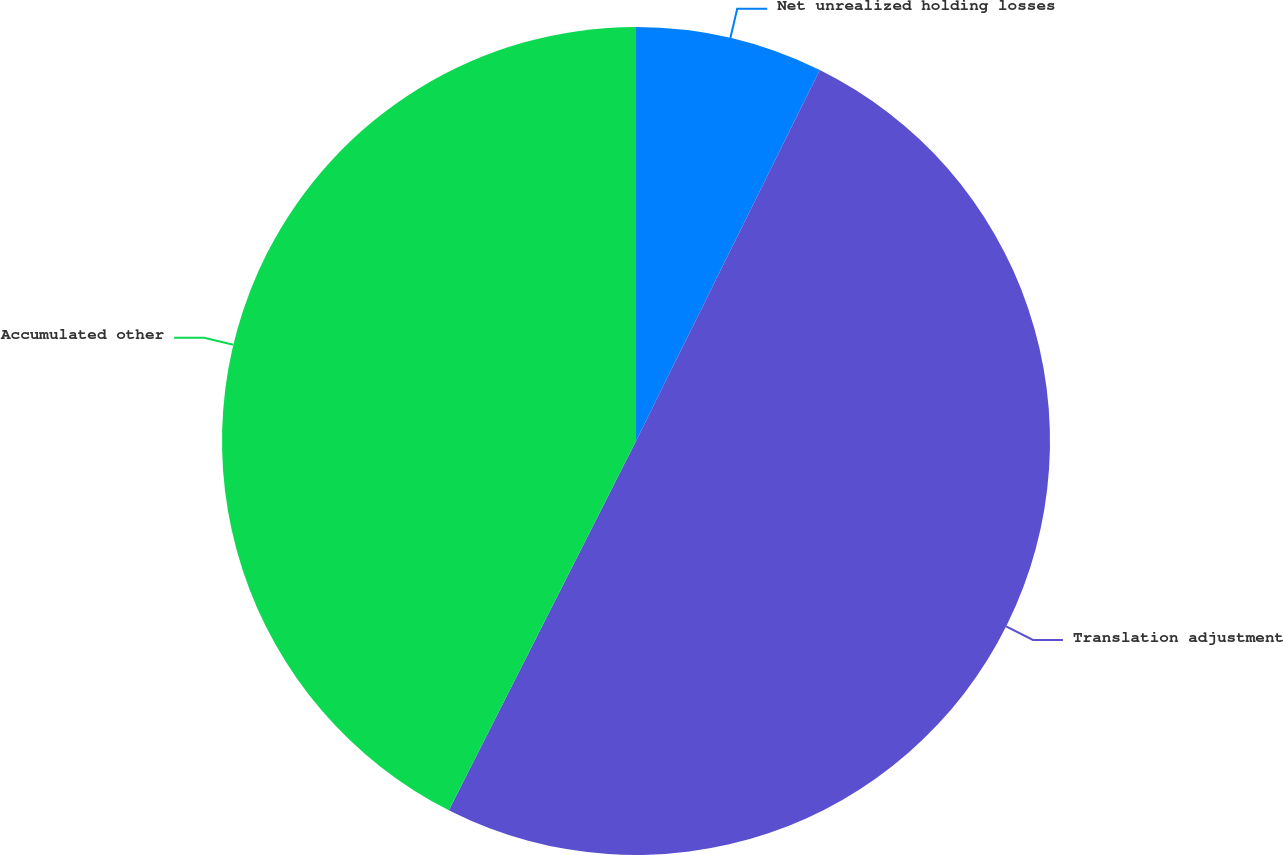Convert chart to OTSL. <chart><loc_0><loc_0><loc_500><loc_500><pie_chart><fcel>Net unrealized holding losses<fcel>Translation adjustment<fcel>Accumulated other<nl><fcel>7.32%<fcel>50.14%<fcel>42.53%<nl></chart> 